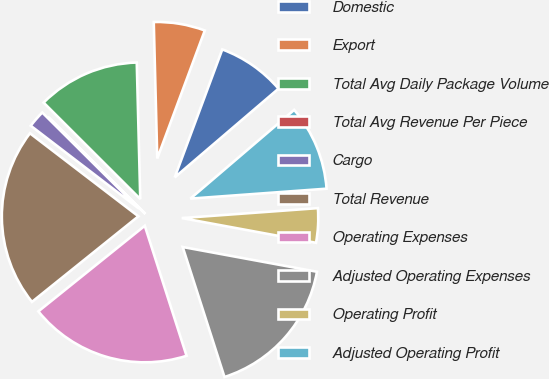Convert chart. <chart><loc_0><loc_0><loc_500><loc_500><pie_chart><fcel>Domestic<fcel>Export<fcel>Total Avg Daily Package Volume<fcel>Total Avg Revenue Per Piece<fcel>Cargo<fcel>Total Revenue<fcel>Operating Expenses<fcel>Adjusted Operating Expenses<fcel>Operating Profit<fcel>Adjusted Operating Profit<nl><fcel>8.08%<fcel>6.07%<fcel>12.11%<fcel>0.03%<fcel>2.05%<fcel>21.18%<fcel>19.17%<fcel>17.15%<fcel>4.06%<fcel>10.1%<nl></chart> 